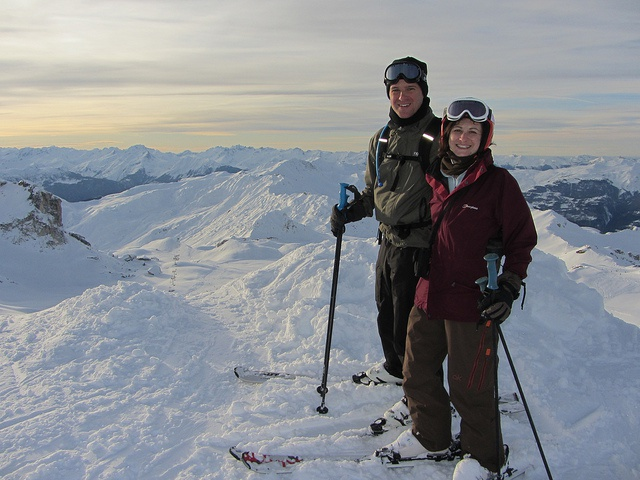Describe the objects in this image and their specific colors. I can see people in lightgray, black, darkgray, gray, and maroon tones, people in lightgray, black, gray, darkgray, and maroon tones, skis in lightgray, darkgray, and gray tones, skis in lightgray and gray tones, and backpack in lightgray, black, white, and gray tones in this image. 